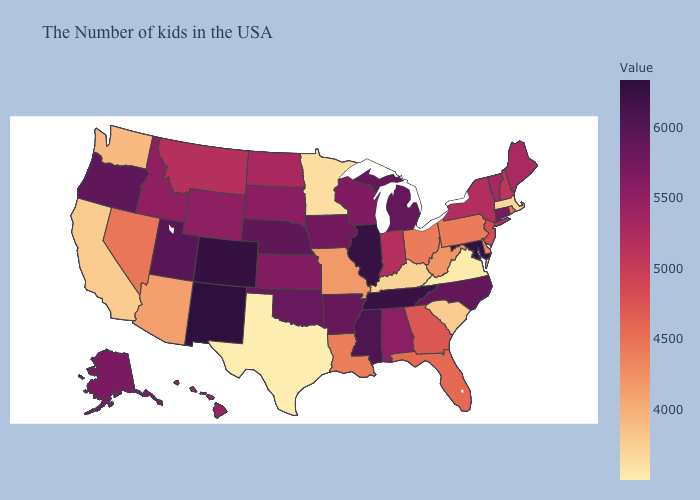Among the states that border Illinois , which have the highest value?
Be succinct. Iowa. Among the states that border Delaware , does Maryland have the lowest value?
Write a very short answer. No. Among the states that border North Carolina , which have the highest value?
Quick response, please. Tennessee. Which states have the lowest value in the USA?
Answer briefly. Texas. Is the legend a continuous bar?
Write a very short answer. Yes. Which states have the highest value in the USA?
Answer briefly. New Mexico. Does Arkansas have the highest value in the South?
Answer briefly. No. 